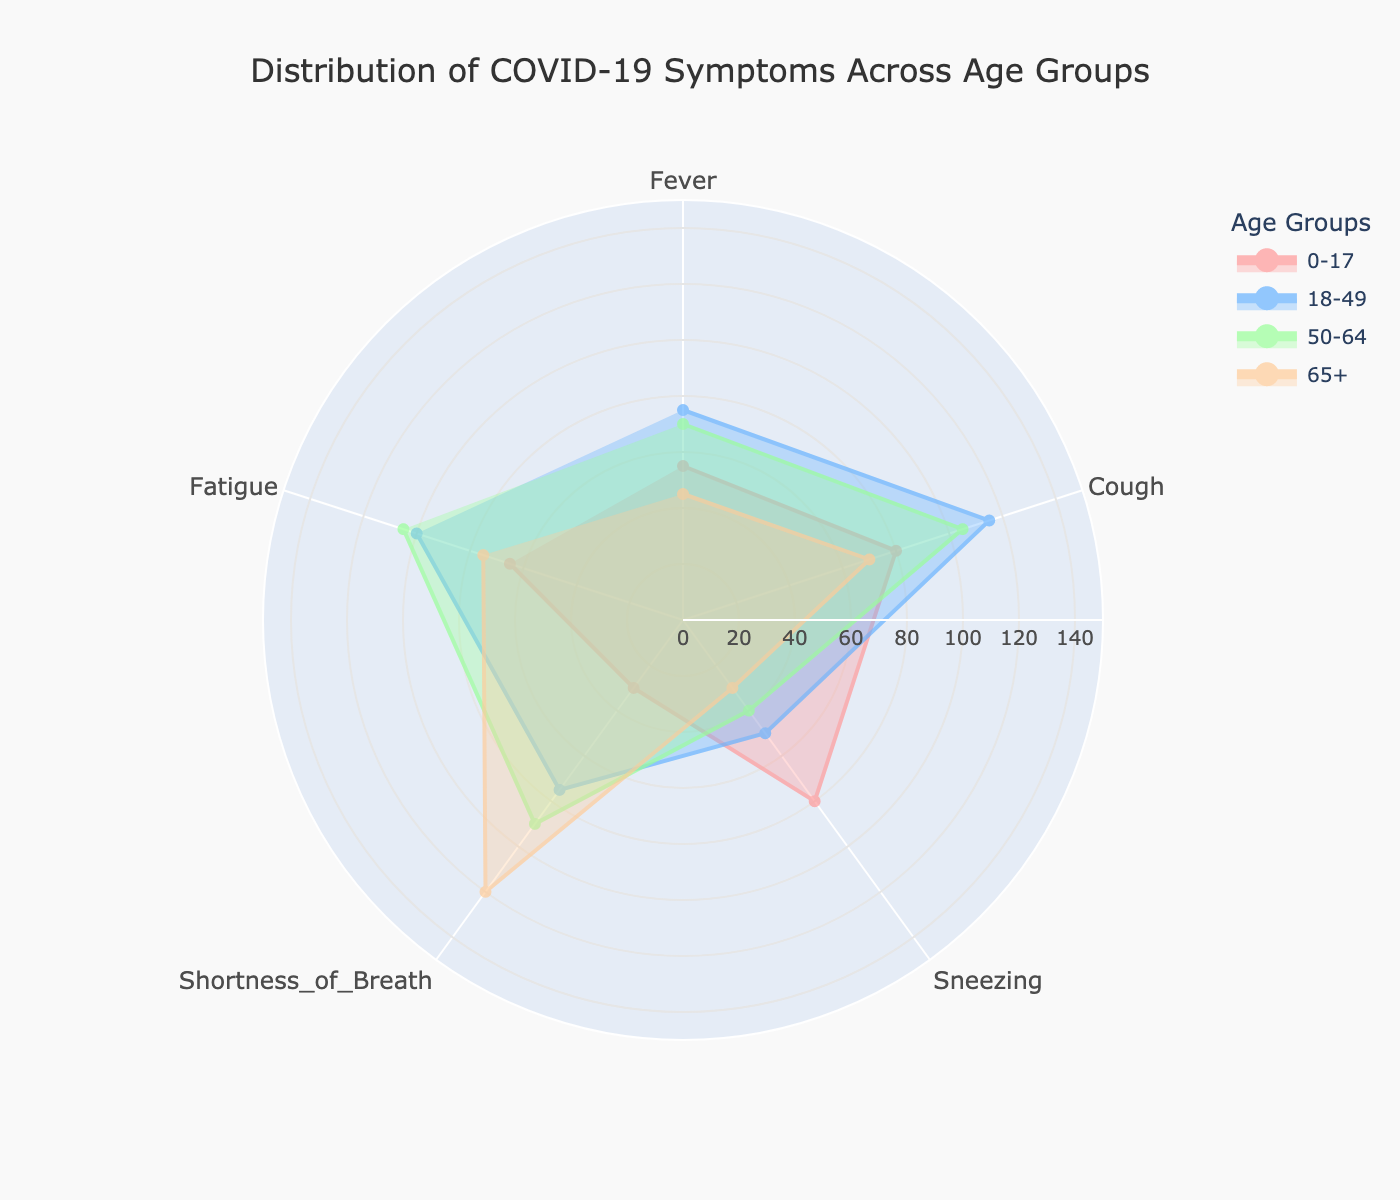What is the title of the polar chart? Look at the top center of the polar chart for the large, bold text which is typically the title of the figure.
Answer: Distribution of COVID-19 Symptoms Across Age Groups Which age group shows the highest frequency of 'Fatigue'? Examine the value for 'Fatigue' in each age group's segment. Look for the highest radial distance along the 'Fatigue' axis.
Answer: 18-49 How many age groups are represented in this polar chart? Count the number of distinct segments or lines represented in the legend on the right side of the chart, as each line corresponds to an age group.
Answer: 4 Which symptom appears less frequent in the '65+' age group for mild cases compared to the '50-64' age group for mild cases? Compare the values for mild cases of each symptom in the '65+' age group to those in the '50-64' age group directly on the chart.
Answer: Sneezing What is the range of the radial axis in the polar chart? Look at the label and tick marks on the radial axis, particularly at the outermost circle to see the maximum value noted.
Answer: 0 to 150 Of the symptoms displayed, which one does the '18-49' age group show the highest frequency of for moderate cases? Look at the values for moderate cases in the '18-49' age group and identify the symptom with the highest value.
Answer: Cough Which two symptoms show roughly similar frequencies for severe cases in the '50-64' age group? Look at the chart and compare the values for each symptom under severe cases for the '50-64' age group.
Answer: Fever and Sneezing What can be said about the severity of 'Shortness of Breath' symptoms in the '65+' age group as compared to the '50-64' age group? Compare the 'Shortness of Breath' values between the '65+' group and the '50-64' group, paying attention to the severity categories (Mild, Moderate, Severe).
Answer: More severe in '65+' Which age group has the lowest frequency of 'Cough' symptoms overall? Sum the values for 'Cough' across all severities in each age group and identify the smallest sum.
Answer: 0-17 What trend do you observe in the severity of 'Fatigue' symptoms across increasing age groups? Look at 'Fatigue' values in the chart for all severity levels and analyze the changes across age groups from youngest to oldest.
Answer: Increases with age 